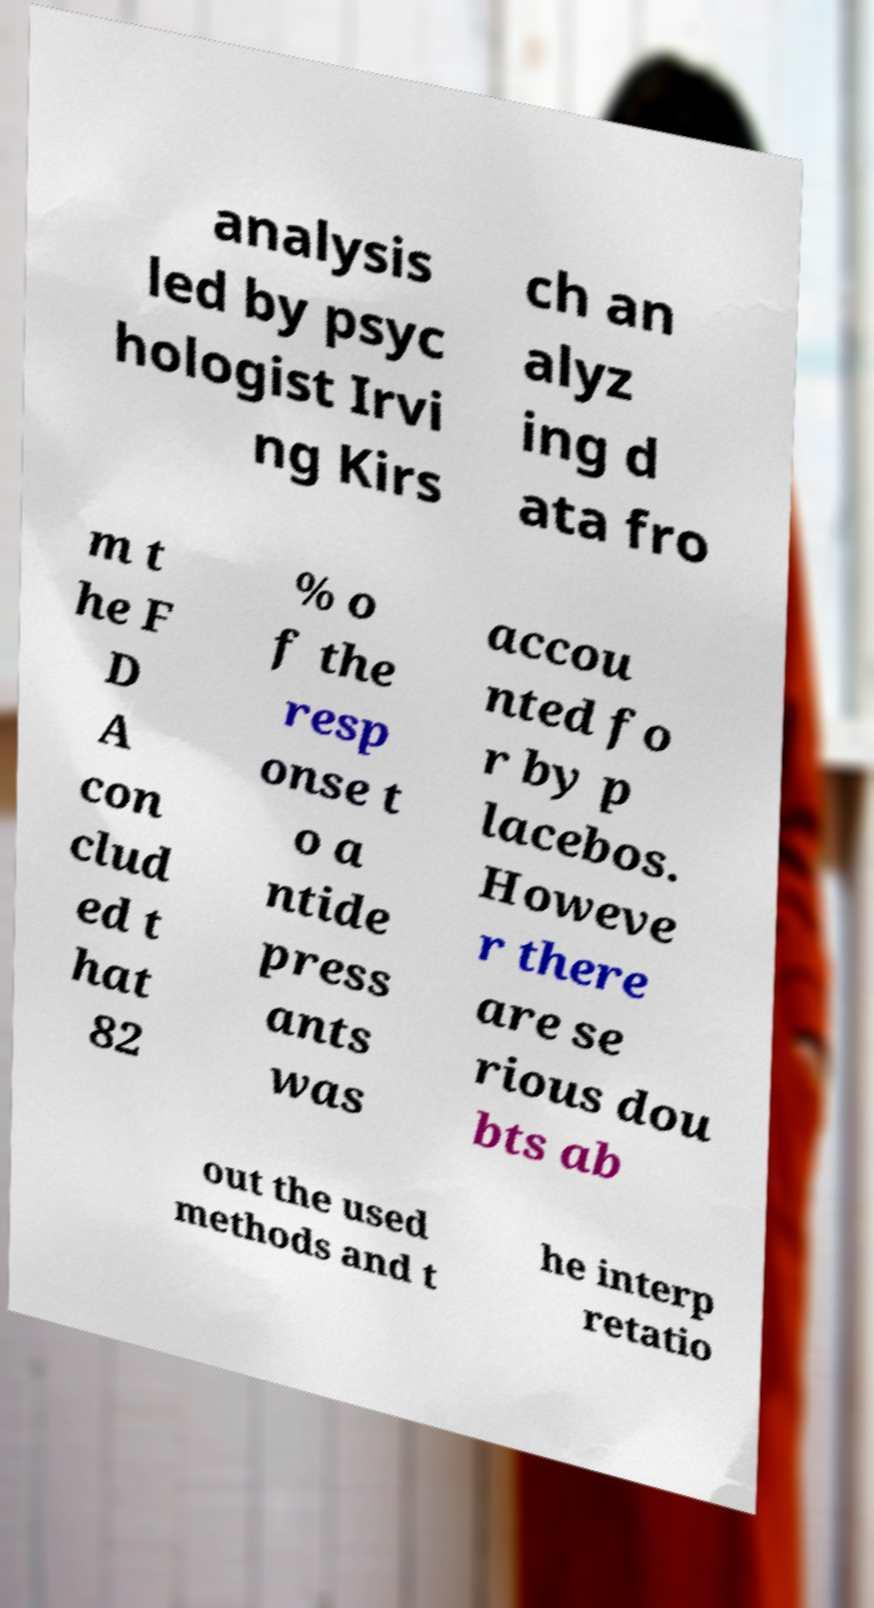For documentation purposes, I need the text within this image transcribed. Could you provide that? analysis led by psyc hologist Irvi ng Kirs ch an alyz ing d ata fro m t he F D A con clud ed t hat 82 % o f the resp onse t o a ntide press ants was accou nted fo r by p lacebos. Howeve r there are se rious dou bts ab out the used methods and t he interp retatio 